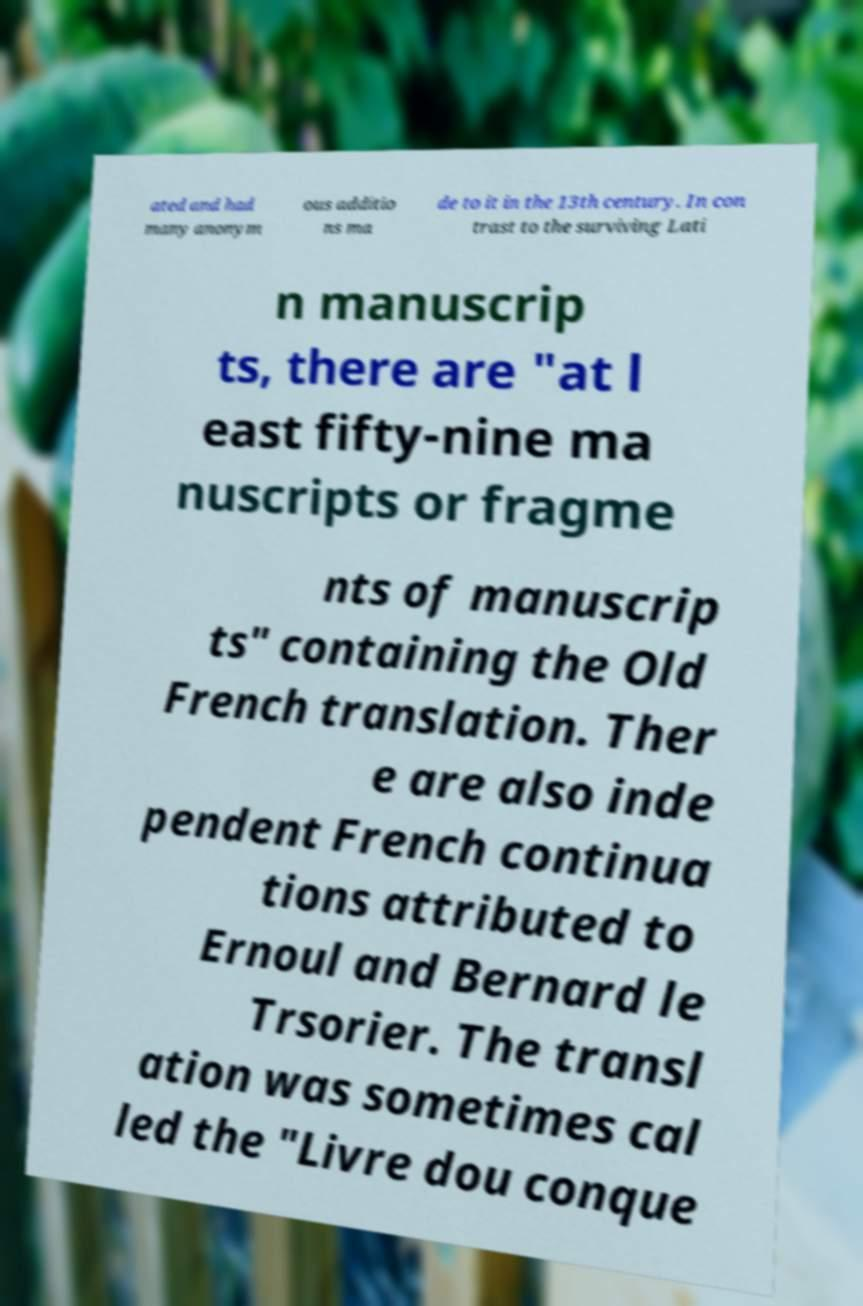Can you read and provide the text displayed in the image?This photo seems to have some interesting text. Can you extract and type it out for me? ated and had many anonym ous additio ns ma de to it in the 13th century. In con trast to the surviving Lati n manuscrip ts, there are "at l east fifty-nine ma nuscripts or fragme nts of manuscrip ts" containing the Old French translation. Ther e are also inde pendent French continua tions attributed to Ernoul and Bernard le Trsorier. The transl ation was sometimes cal led the "Livre dou conque 